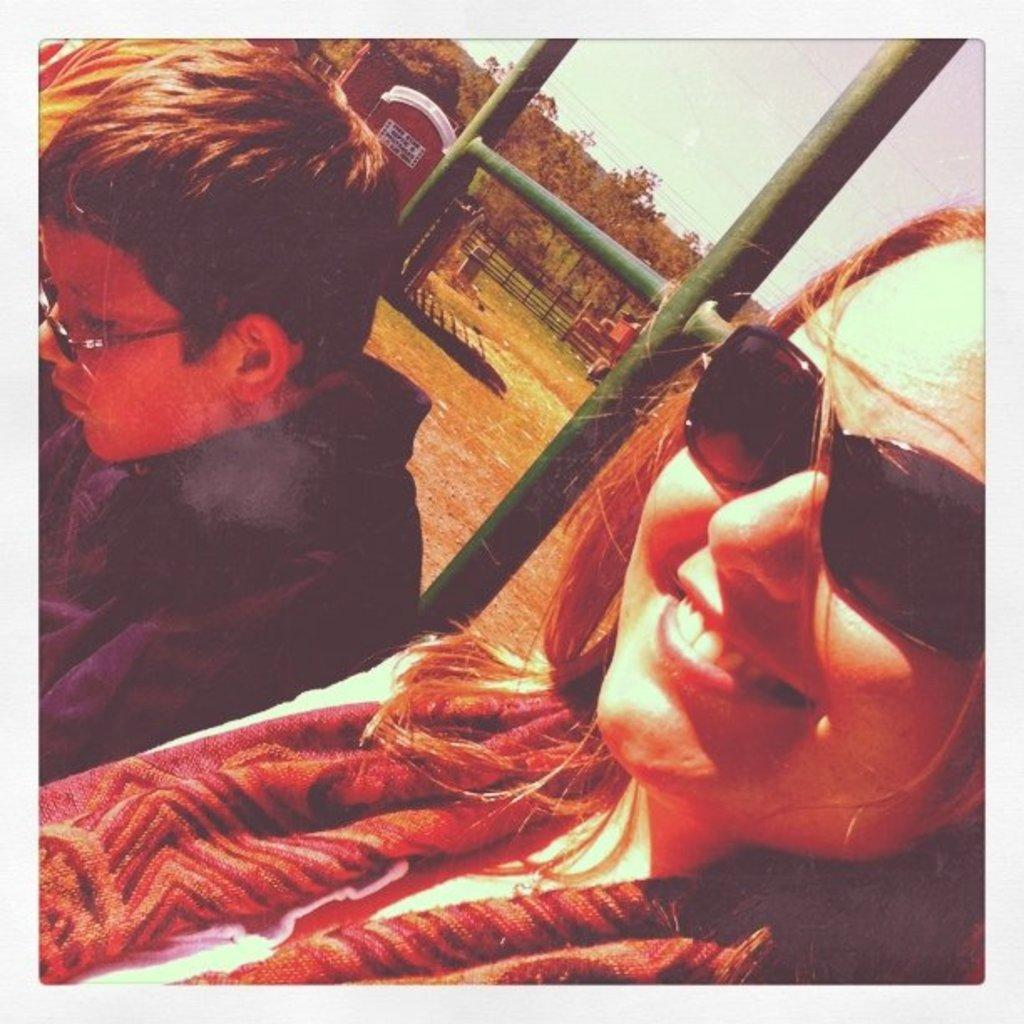How many people are present in the image? There are two persons in the image. What type of structure can be seen in the background? There is a wooden house in the background of the image. What type of vegetation is visible in the image? There are trees in the image. What is the purpose of the fencing in the image? The fencing in the image serves as a barrier or boundary. What part of the natural environment is visible in the image? The sky is visible in the image. What type of pollution can be seen in the image? There is no pollution visible in the image. What type of brick is used to construct the zoo in the image? There is no zoo present in the image, and therefore no brick construction can be observed. 